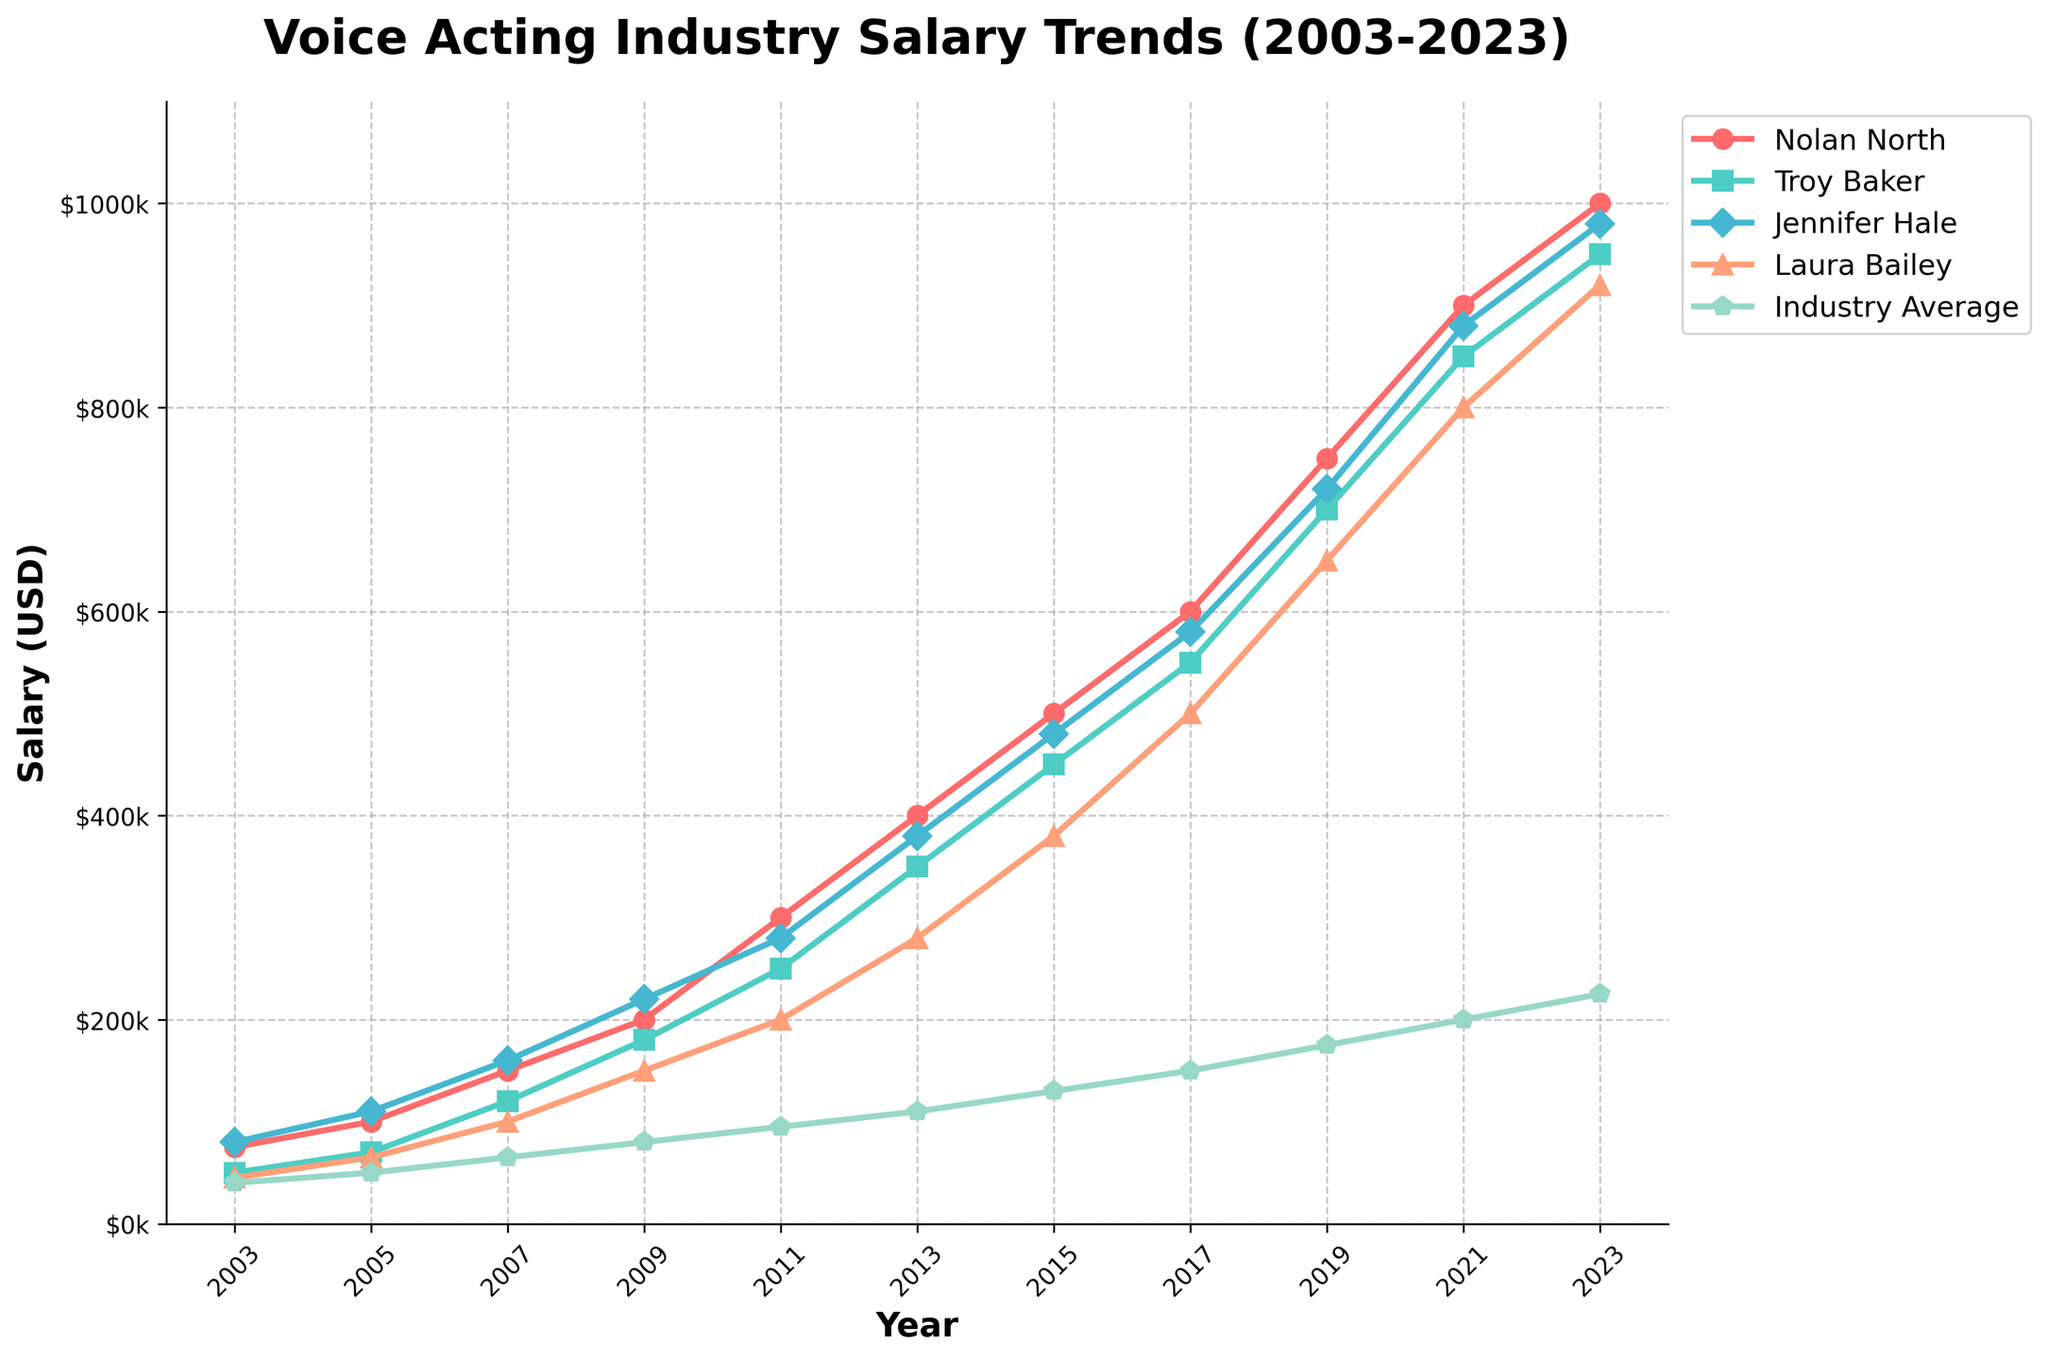What's the salary trend for Nolan North from 2003 to 2023? To determine the salary trend for Nolan North from 2003 to 2023, observe the line representing Nolan North in the figure. We see a consistent upward trajectory in his salary, starting from $75,000 in 2003 and reaching $1,000,000 in 2023.
Answer: Increasing How much more was Nolan North earning in 2023 compared to the industry average? To find the difference in earnings between Nolan North and the industry average in 2023, subtract the industry average salary from Nolan North's salary for that year: $1,000,000 - $225,000 = $775,000.
Answer: $775,000 more In which year did Laura Bailey's salary surpass the industry average for the first time? To determine the first year Laura Bailey's salary surpassed the industry average, compare her salary to the industry average yearly. It happens in 2013, where Laura's salary ($280,000) exceeds the industry average ($110,000).
Answer: 2013 Who had the highest salary in 2017, and what was it? To find the highest salary in 2017, compare the salaries of Nolan North, Troy Baker, Jennifer Hale, and Laura Bailey. Nolan North had the highest salary at $600,000.
Answer: Nolan North, $600,000 By how much did Jennifer Hale's salary increase from 2003 to 2023? To find the increase, subtract Jennifer Hale's salary in 2003 from her salary in 2023: $980,000 - $80,000 = $900,000.
Answer: $900,000 Which year saw the biggest single-year salary jump for Nolan North? Analyzing the chart, the biggest single-year increase for Nolan North occurred between 2011 and 2013, where his salary jumped from $300,000 to $400,000, an increase of $100,000.
Answer: 2011-2013 How does the salary growth of Troy Baker compare to Jennifer Hale from 2009 to 2013? Calculate the salary increases for both. Troy Baker's salary rose from $180,000 to $350,000 (an increase of $170,000), while Jennifer Hale's salary went from $220,000 to $380,000 (an increase of $160,000). So, Troy Baker's salary grew by $10,000 more than Jennifer Hale's.
Answer: Troy Baker's grew $10,000 more What is the average salary of Laura Bailey over the two decades? Sum Laura Bailey's salaries from each year and divide by the number of years: (45000 + 65000 + 100000 + 150000 + 200000 + 280000 + 380000 + 500000 + 650000 + 800000 + 920000) / 11 = $382,727.27.
Answer: $382,727.27 Which performer had the most consistent salary growth over the years? By visually inspecting the smoothness and steepness of the lines, Nolan North's line is the most consistently upward with no dips or stagnation periods, representing the most consistent and steepest salary growth.
Answer: Nolan North 